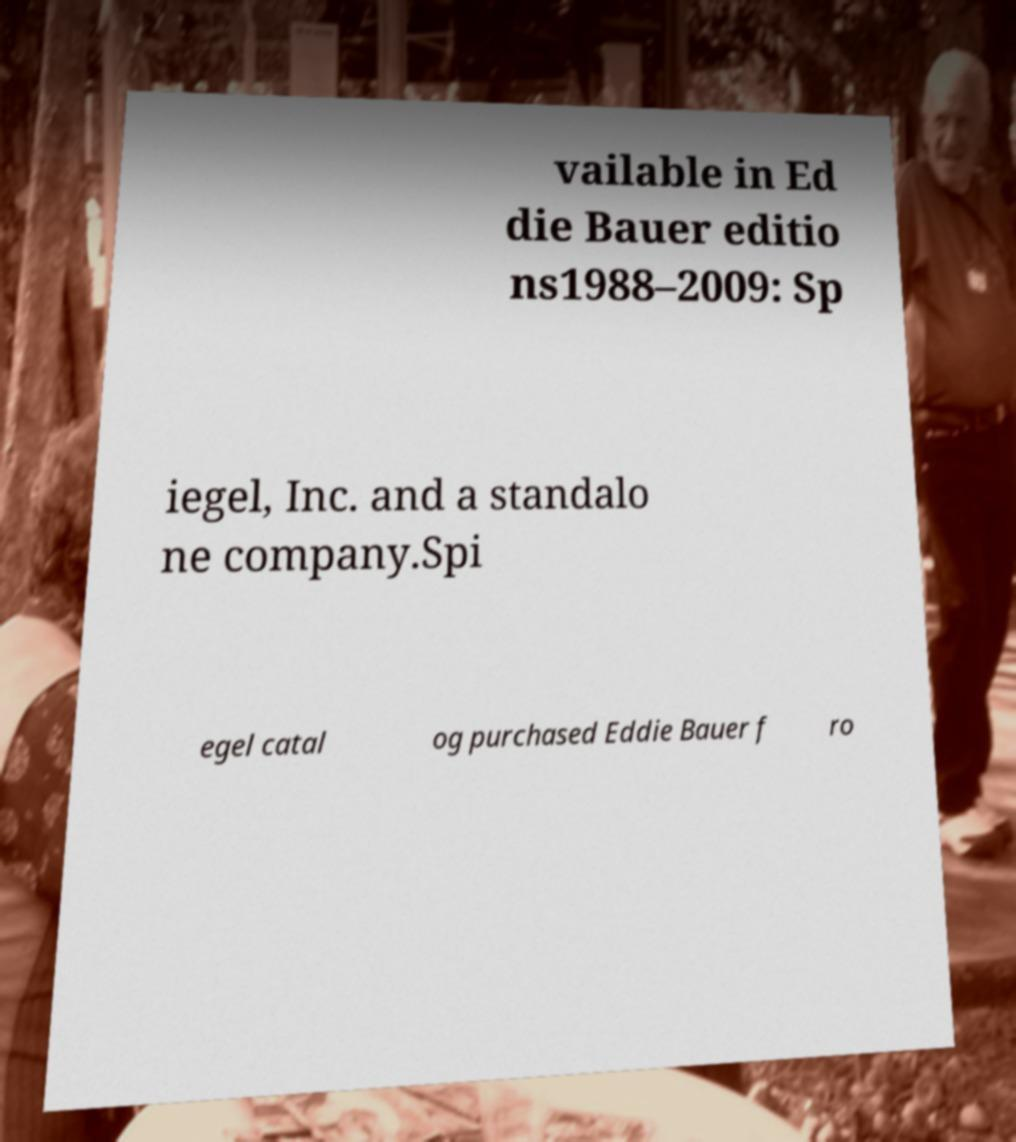Please identify and transcribe the text found in this image. vailable in Ed die Bauer editio ns1988–2009: Sp iegel, Inc. and a standalo ne company.Spi egel catal og purchased Eddie Bauer f ro 